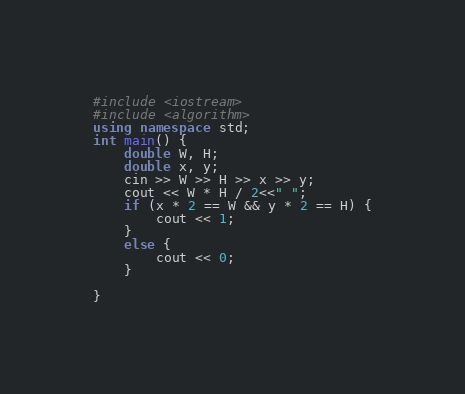Convert code to text. <code><loc_0><loc_0><loc_500><loc_500><_C++_>#include <iostream>
#include <algorithm>
using namespace std;
int main() {
	double W, H;
	double x, y;
	cin >> W >> H >> x >> y;
	cout << W * H / 2<<" ";
	if (x * 2 == W && y * 2 == H) {
		cout << 1;
	}
	else {
		cout << 0;
	}

}</code> 